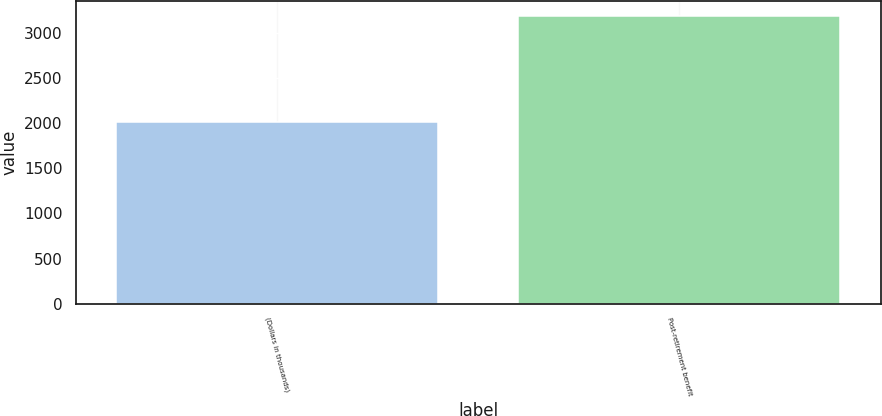Convert chart to OTSL. <chart><loc_0><loc_0><loc_500><loc_500><bar_chart><fcel>(Dollars in thousands)<fcel>Post-retirement benefit<nl><fcel>2014<fcel>3196<nl></chart> 